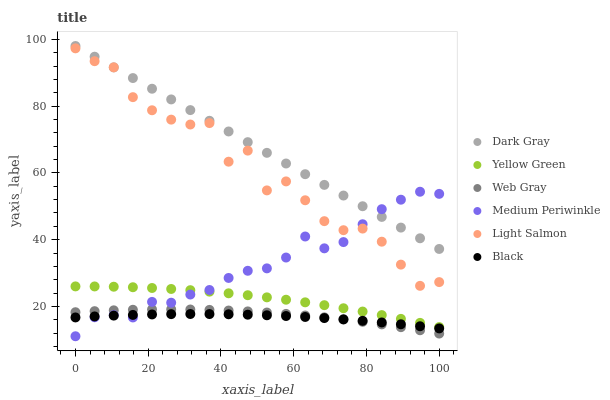Does Black have the minimum area under the curve?
Answer yes or no. Yes. Does Dark Gray have the maximum area under the curve?
Answer yes or no. Yes. Does Web Gray have the minimum area under the curve?
Answer yes or no. No. Does Web Gray have the maximum area under the curve?
Answer yes or no. No. Is Dark Gray the smoothest?
Answer yes or no. Yes. Is Light Salmon the roughest?
Answer yes or no. Yes. Is Web Gray the smoothest?
Answer yes or no. No. Is Web Gray the roughest?
Answer yes or no. No. Does Medium Periwinkle have the lowest value?
Answer yes or no. Yes. Does Web Gray have the lowest value?
Answer yes or no. No. Does Dark Gray have the highest value?
Answer yes or no. Yes. Does Web Gray have the highest value?
Answer yes or no. No. Is Web Gray less than Dark Gray?
Answer yes or no. Yes. Is Light Salmon greater than Black?
Answer yes or no. Yes. Does Medium Periwinkle intersect Light Salmon?
Answer yes or no. Yes. Is Medium Periwinkle less than Light Salmon?
Answer yes or no. No. Is Medium Periwinkle greater than Light Salmon?
Answer yes or no. No. Does Web Gray intersect Dark Gray?
Answer yes or no. No. 